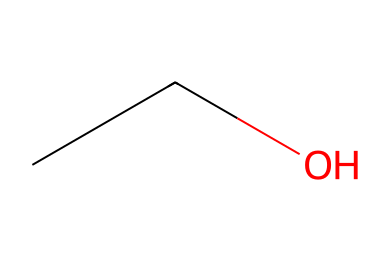What is the name of this chemical? The SMILES representation "CCO" corresponds to the structure of ethanol, which is a common alcohol used in hand sanitizers. The two carbon atoms and one oxygen atom indicate its identity as ethanol.
Answer: ethanol How many carbon atoms are in this compound? In the SMILES "CCO", the two 'C's represent that there are two carbon atoms present in the structure. Each 'C' corresponds to one carbon atom.
Answer: 2 What type of functional group is present in ethanol? The SMILES notation "CCO" indicates the presence of an alcohol functional group, which is represented by the -OH (hydroxyl) group attached to one of the carbon atoms. This information can be inferred from the presence of the oxygen atom following the carbon chain.
Answer: alcohol What is the total number of hydrogen atoms in ethanol? To determine the number of hydrogen atoms, we look at the structure given by the SMILES 'CCO'. Ether would typically have the formula CnH2n+2, and since there are 2 carbon atoms (n=2), the formula C2H6 applies, but we subtract one hydrogen for the -OH group, leading to 5 hydrogen atoms total.
Answer: 6 Is ethanol a saturated or unsaturated compound? Ethanol contains no double or triple bonds among the carbon atoms, which indicates that it is a saturated compound. The presence of only single bonds in the carbon chain suggests that all possible hydrogen bonding sites are utilized, thus confirming its saturation.
Answer: saturated What is the main use of ethanol in hand sanitizers? Ethanol serves as the active ingredient in hand sanitizers due to its effectiveness in killing germs and bacteria, which is attributed to its polar and non-polar characteristics that allow it to disrupt the lipid membranes of pathogens.
Answer: disinfectant 